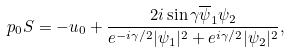Convert formula to latex. <formula><loc_0><loc_0><loc_500><loc_500>p _ { 0 } S = - u _ { 0 } + \frac { 2 i \sin \gamma \overline { \psi } _ { 1 } \psi _ { 2 } } { e ^ { - i \gamma / 2 } | \psi _ { 1 } | ^ { 2 } + e ^ { i \gamma / 2 } | \psi _ { 2 } | ^ { 2 } } ,</formula> 